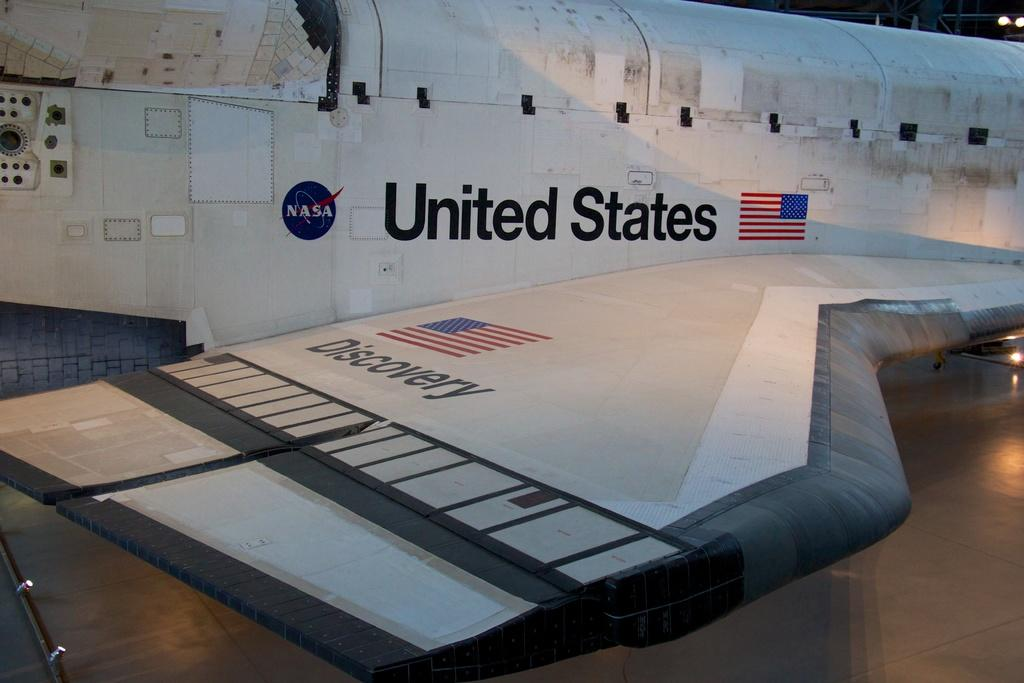<image>
Offer a succinct explanation of the picture presented. Parked airplace that has "United States" on the side. 